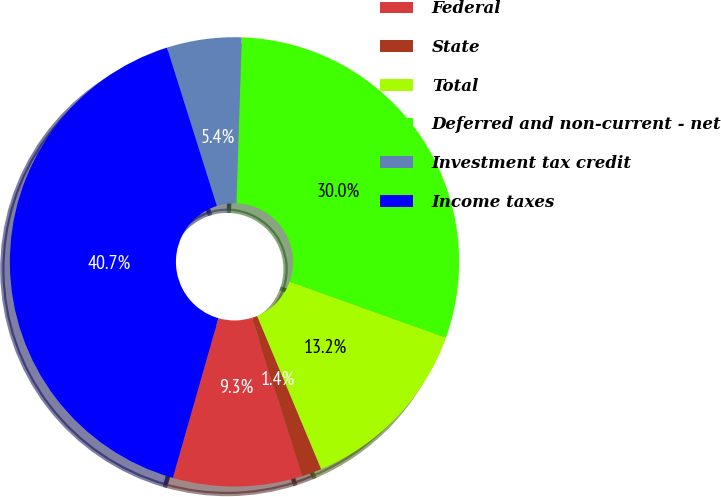Convert chart to OTSL. <chart><loc_0><loc_0><loc_500><loc_500><pie_chart><fcel>Federal<fcel>State<fcel>Total<fcel>Deferred and non-current - net<fcel>Investment tax credit<fcel>Income taxes<nl><fcel>9.29%<fcel>1.44%<fcel>13.22%<fcel>29.96%<fcel>5.37%<fcel>40.72%<nl></chart> 